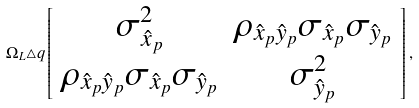<formula> <loc_0><loc_0><loc_500><loc_500>\Omega _ { L } \triangle q \left [ \begin{array} { c c } \sigma _ { \hat { x } _ { p } } ^ { 2 } & \rho _ { \hat { x } _ { p } \hat { y } _ { p } } \sigma _ { \hat { x } _ { p } } \sigma _ { \hat { y } _ { p } } \\ \rho _ { \hat { x } _ { p } \hat { y } _ { p } } \sigma _ { \hat { x } _ { p } } \sigma _ { \hat { y } _ { p } } & \sigma _ { \hat { y } _ { p } } ^ { 2 } \\ \end{array} \right ] ,</formula> 